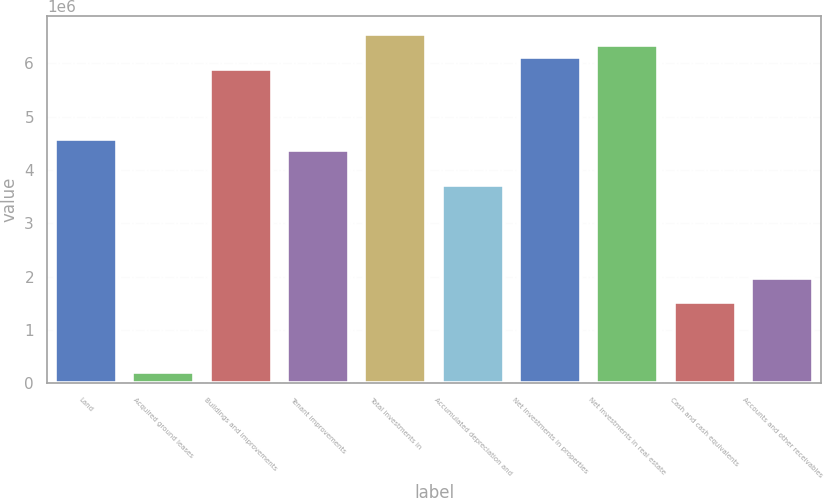<chart> <loc_0><loc_0><loc_500><loc_500><bar_chart><fcel>Land<fcel>Acquired ground leases<fcel>Buildings and improvements<fcel>Tenant improvements<fcel>Total investments in<fcel>Accumulated depreciation and<fcel>Net investments in properties<fcel>Net investments in real estate<fcel>Cash and cash equivalents<fcel>Accounts and other receivables<nl><fcel>4.59046e+06<fcel>219110<fcel>5.90187e+06<fcel>4.3719e+06<fcel>6.55757e+06<fcel>3.71619e+06<fcel>6.12044e+06<fcel>6.33901e+06<fcel>1.53052e+06<fcel>1.96765e+06<nl></chart> 